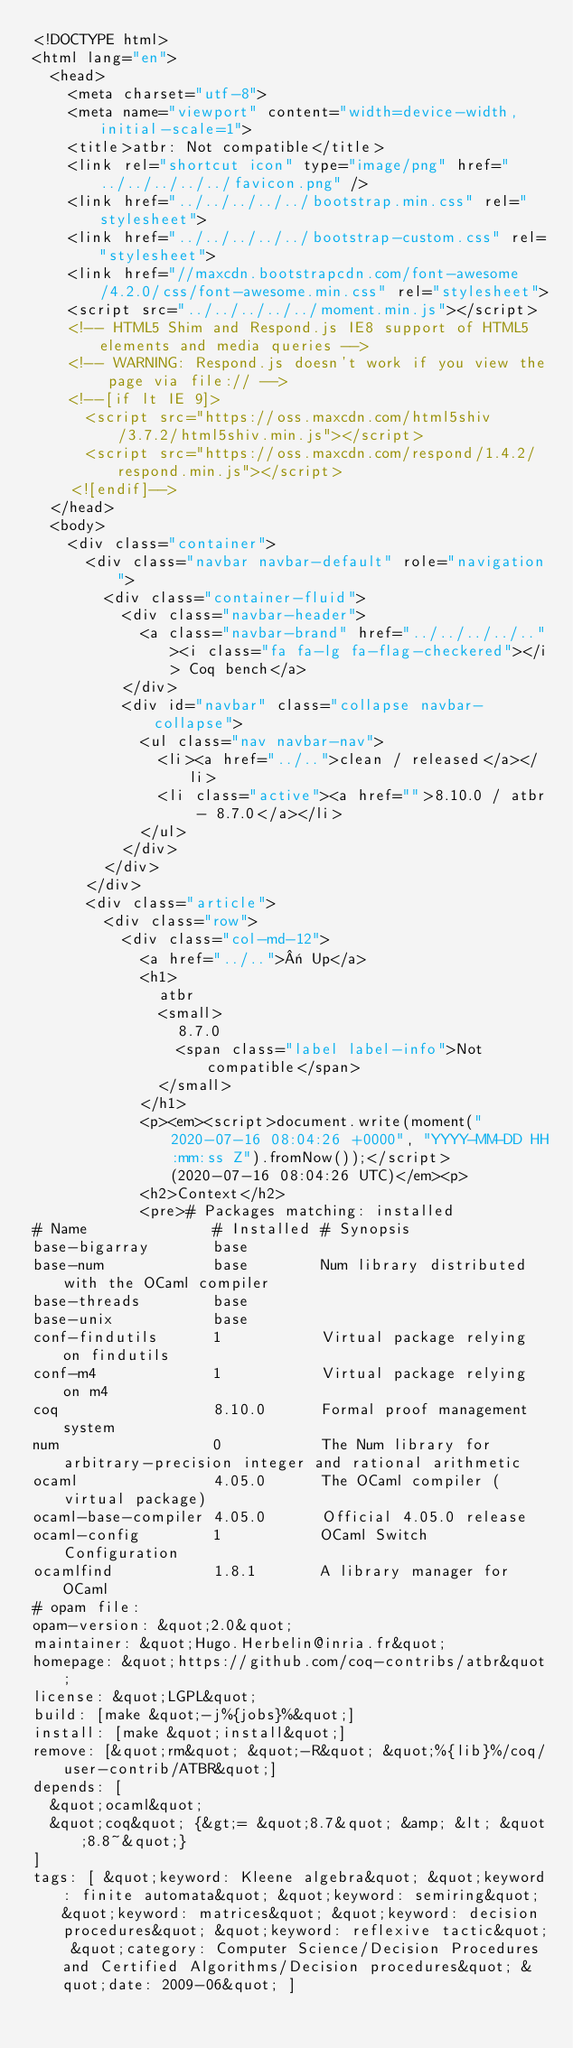Convert code to text. <code><loc_0><loc_0><loc_500><loc_500><_HTML_><!DOCTYPE html>
<html lang="en">
  <head>
    <meta charset="utf-8">
    <meta name="viewport" content="width=device-width, initial-scale=1">
    <title>atbr: Not compatible</title>
    <link rel="shortcut icon" type="image/png" href="../../../../../favicon.png" />
    <link href="../../../../../bootstrap.min.css" rel="stylesheet">
    <link href="../../../../../bootstrap-custom.css" rel="stylesheet">
    <link href="//maxcdn.bootstrapcdn.com/font-awesome/4.2.0/css/font-awesome.min.css" rel="stylesheet">
    <script src="../../../../../moment.min.js"></script>
    <!-- HTML5 Shim and Respond.js IE8 support of HTML5 elements and media queries -->
    <!-- WARNING: Respond.js doesn't work if you view the page via file:// -->
    <!--[if lt IE 9]>
      <script src="https://oss.maxcdn.com/html5shiv/3.7.2/html5shiv.min.js"></script>
      <script src="https://oss.maxcdn.com/respond/1.4.2/respond.min.js"></script>
    <![endif]-->
  </head>
  <body>
    <div class="container">
      <div class="navbar navbar-default" role="navigation">
        <div class="container-fluid">
          <div class="navbar-header">
            <a class="navbar-brand" href="../../../../.."><i class="fa fa-lg fa-flag-checkered"></i> Coq bench</a>
          </div>
          <div id="navbar" class="collapse navbar-collapse">
            <ul class="nav navbar-nav">
              <li><a href="../..">clean / released</a></li>
              <li class="active"><a href="">8.10.0 / atbr - 8.7.0</a></li>
            </ul>
          </div>
        </div>
      </div>
      <div class="article">
        <div class="row">
          <div class="col-md-12">
            <a href="../..">« Up</a>
            <h1>
              atbr
              <small>
                8.7.0
                <span class="label label-info">Not compatible</span>
              </small>
            </h1>
            <p><em><script>document.write(moment("2020-07-16 08:04:26 +0000", "YYYY-MM-DD HH:mm:ss Z").fromNow());</script> (2020-07-16 08:04:26 UTC)</em><p>
            <h2>Context</h2>
            <pre># Packages matching: installed
# Name              # Installed # Synopsis
base-bigarray       base
base-num            base        Num library distributed with the OCaml compiler
base-threads        base
base-unix           base
conf-findutils      1           Virtual package relying on findutils
conf-m4             1           Virtual package relying on m4
coq                 8.10.0      Formal proof management system
num                 0           The Num library for arbitrary-precision integer and rational arithmetic
ocaml               4.05.0      The OCaml compiler (virtual package)
ocaml-base-compiler 4.05.0      Official 4.05.0 release
ocaml-config        1           OCaml Switch Configuration
ocamlfind           1.8.1       A library manager for OCaml
# opam file:
opam-version: &quot;2.0&quot;
maintainer: &quot;Hugo.Herbelin@inria.fr&quot;
homepage: &quot;https://github.com/coq-contribs/atbr&quot;
license: &quot;LGPL&quot;
build: [make &quot;-j%{jobs}%&quot;]
install: [make &quot;install&quot;]
remove: [&quot;rm&quot; &quot;-R&quot; &quot;%{lib}%/coq/user-contrib/ATBR&quot;]
depends: [
  &quot;ocaml&quot;
  &quot;coq&quot; {&gt;= &quot;8.7&quot; &amp; &lt; &quot;8.8~&quot;}
]
tags: [ &quot;keyword: Kleene algebra&quot; &quot;keyword: finite automata&quot; &quot;keyword: semiring&quot; &quot;keyword: matrices&quot; &quot;keyword: decision procedures&quot; &quot;keyword: reflexive tactic&quot; &quot;category: Computer Science/Decision Procedures and Certified Algorithms/Decision procedures&quot; &quot;date: 2009-06&quot; ]</code> 